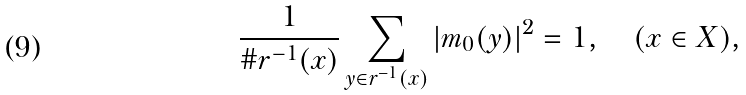<formula> <loc_0><loc_0><loc_500><loc_500>\frac { 1 } { \# r ^ { - 1 } ( x ) } \sum _ { y \in r ^ { - 1 } ( x ) } | m _ { 0 } ( y ) | ^ { 2 } = 1 , \quad ( x \in X ) ,</formula> 